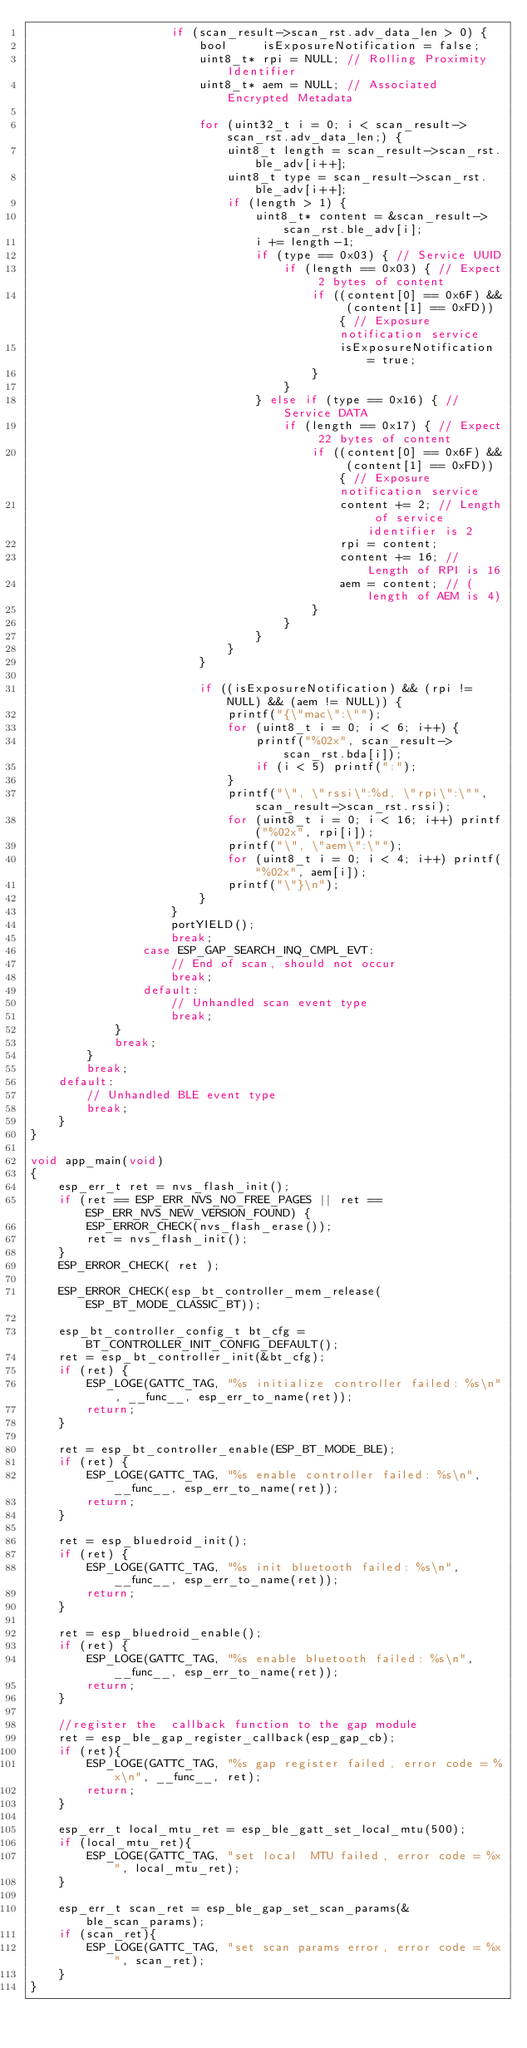<code> <loc_0><loc_0><loc_500><loc_500><_C_>					if (scan_result->scan_rst.adv_data_len > 0) {
						bool     isExposureNotification = false;
						uint8_t* rpi = NULL; // Rolling Proximity Identifier
						uint8_t* aem = NULL; // Associated Encrypted Metadata
						
						for (uint32_t i = 0; i < scan_result->scan_rst.adv_data_len;) {
							uint8_t length = scan_result->scan_rst.ble_adv[i++];
							uint8_t type = scan_result->scan_rst.ble_adv[i++];
							if (length > 1) {
								uint8_t* content = &scan_result->scan_rst.ble_adv[i];
								i += length-1;
								if (type == 0x03) { // Service UUID
									if (length == 0x03) { // Expect 2 bytes of content
										if ((content[0] == 0x6F) && (content[1] == 0xFD)) { // Exposure notification service
											isExposureNotification = true;
										}
									}
								} else if (type == 0x16) { // Service DATA
									if (length == 0x17) { // Expect 22 bytes of content
										if ((content[0] == 0x6F) && (content[1] == 0xFD)) { // Exposure notification service
											content += 2; // Length of service identifier is 2
											rpi = content;
											content += 16; // Length of RPI is 16
											aem = content; // (length of AEM is 4)
										}
									}
								}
							}
						}
						
						if ((isExposureNotification) && (rpi != NULL) && (aem != NULL)) {
							printf("{\"mac\":\"");
							for (uint8_t i = 0; i < 6; i++) {
								printf("%02x", scan_result->scan_rst.bda[i]);
								if (i < 5) printf(":");
							}
							printf("\", \"rssi\":%d, \"rpi\":\"", scan_result->scan_rst.rssi);
							for (uint8_t i = 0; i < 16; i++) printf("%02x", rpi[i]);
							printf("\", \"aem\":\"");
							for (uint8_t i = 0; i < 4; i++) printf("%02x", aem[i]);
							printf("\"}\n");
						}
					}
					portYIELD();
					break;
				case ESP_GAP_SEARCH_INQ_CMPL_EVT:
					// End of scan, should not occur
					break;
				default:
					// Unhandled scan event type
					break;
			}
			break;
		}
		break;
	default:
		// Unhandled BLE event type
		break;
	}
}

void app_main(void)
{
	esp_err_t ret = nvs_flash_init();
	if (ret == ESP_ERR_NVS_NO_FREE_PAGES || ret == ESP_ERR_NVS_NEW_VERSION_FOUND) {
		ESP_ERROR_CHECK(nvs_flash_erase());
		ret = nvs_flash_init();
	}
	ESP_ERROR_CHECK( ret );

	ESP_ERROR_CHECK(esp_bt_controller_mem_release(ESP_BT_MODE_CLASSIC_BT));

	esp_bt_controller_config_t bt_cfg = BT_CONTROLLER_INIT_CONFIG_DEFAULT();
	ret = esp_bt_controller_init(&bt_cfg);
	if (ret) {
		ESP_LOGE(GATTC_TAG, "%s initialize controller failed: %s\n", __func__, esp_err_to_name(ret));
		return;
	}

	ret = esp_bt_controller_enable(ESP_BT_MODE_BLE);
	if (ret) {
		ESP_LOGE(GATTC_TAG, "%s enable controller failed: %s\n", __func__, esp_err_to_name(ret));
		return;
	}

	ret = esp_bluedroid_init();
	if (ret) {
		ESP_LOGE(GATTC_TAG, "%s init bluetooth failed: %s\n", __func__, esp_err_to_name(ret));
		return;
	}

	ret = esp_bluedroid_enable();
	if (ret) {
		ESP_LOGE(GATTC_TAG, "%s enable bluetooth failed: %s\n", __func__, esp_err_to_name(ret));
		return;
	}

	//register the  callback function to the gap module
	ret = esp_ble_gap_register_callback(esp_gap_cb);
	if (ret){
		ESP_LOGE(GATTC_TAG, "%s gap register failed, error code = %x\n", __func__, ret);
		return;
	}
	
	esp_err_t local_mtu_ret = esp_ble_gatt_set_local_mtu(500);
	if (local_mtu_ret){
		ESP_LOGE(GATTC_TAG, "set local  MTU failed, error code = %x", local_mtu_ret);
	}
	
	esp_err_t scan_ret = esp_ble_gap_set_scan_params(&ble_scan_params);
	if (scan_ret){
		ESP_LOGE(GATTC_TAG, "set scan params error, error code = %x", scan_ret);
	}
}

</code> 